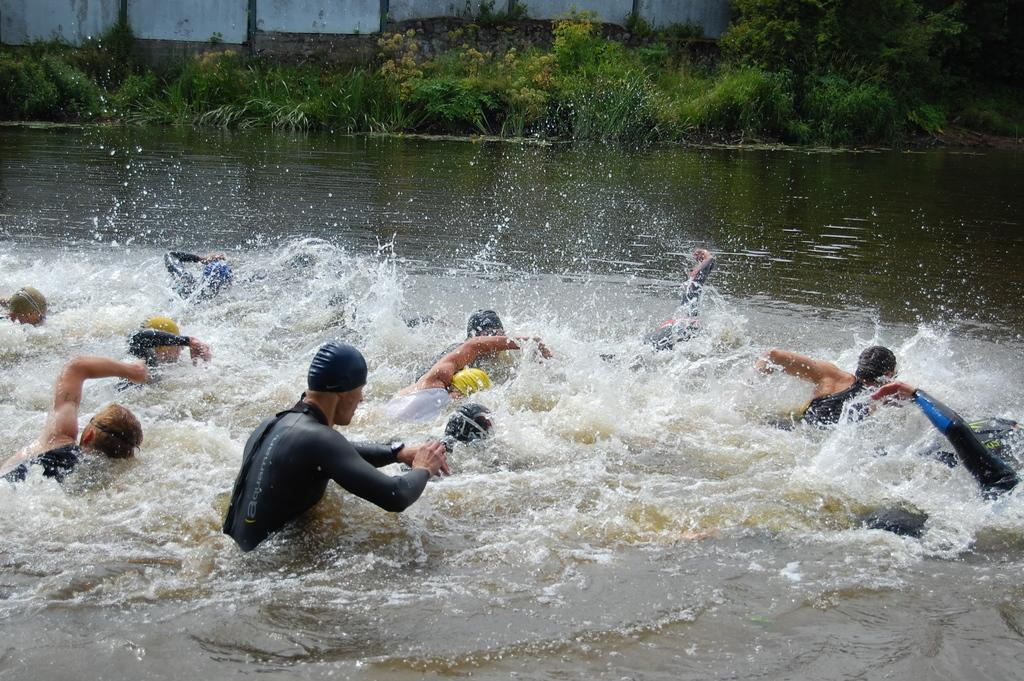What are the people in the image doing? There is a group of persons in the water in the image. What can be seen in the background of the image? There is a wall, plants, and trees in the background of the image. What type of rabbit can be seen jumping over the wall in the image? There is no rabbit present in the image, and therefore no such activity can be observed. 